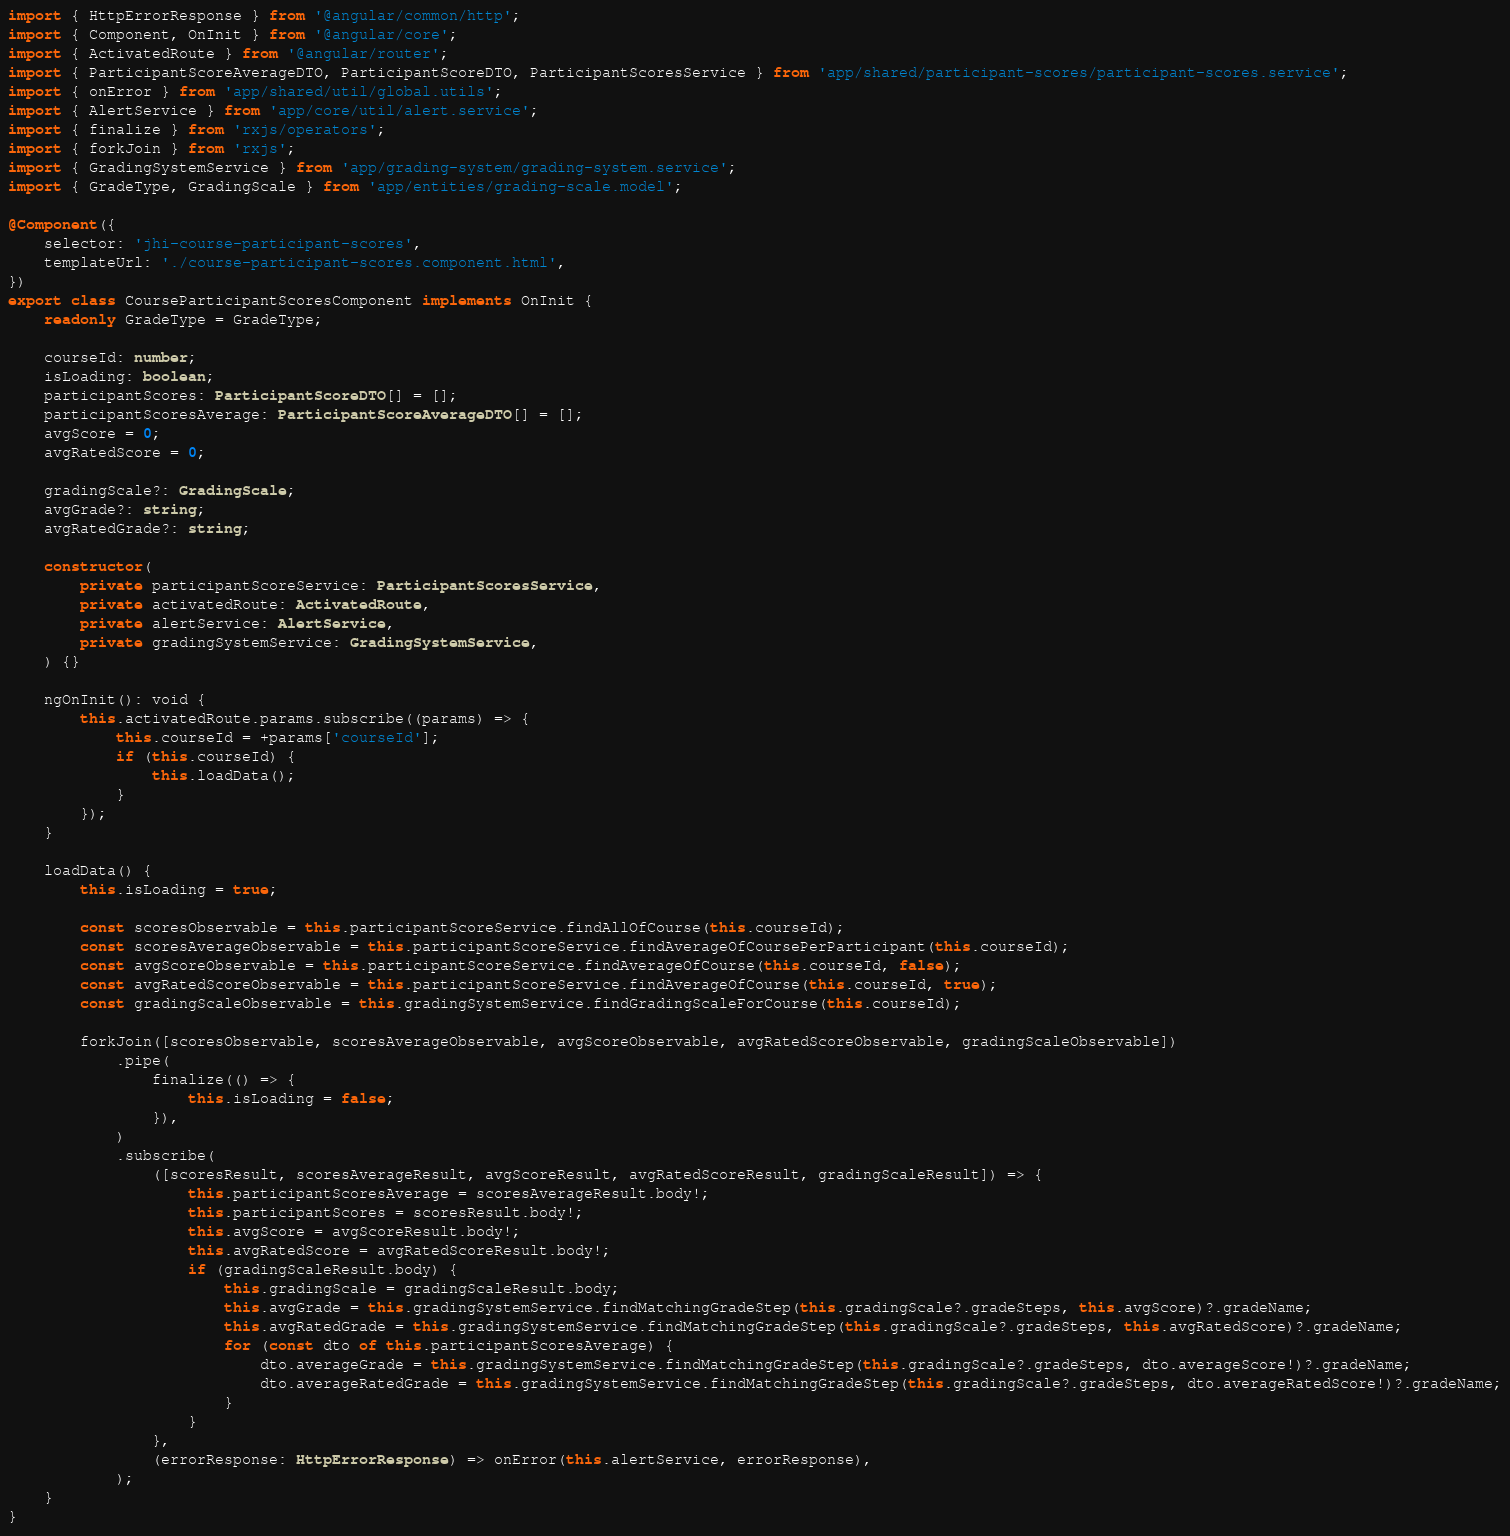Convert code to text. <code><loc_0><loc_0><loc_500><loc_500><_TypeScript_>import { HttpErrorResponse } from '@angular/common/http';
import { Component, OnInit } from '@angular/core';
import { ActivatedRoute } from '@angular/router';
import { ParticipantScoreAverageDTO, ParticipantScoreDTO, ParticipantScoresService } from 'app/shared/participant-scores/participant-scores.service';
import { onError } from 'app/shared/util/global.utils';
import { AlertService } from 'app/core/util/alert.service';
import { finalize } from 'rxjs/operators';
import { forkJoin } from 'rxjs';
import { GradingSystemService } from 'app/grading-system/grading-system.service';
import { GradeType, GradingScale } from 'app/entities/grading-scale.model';

@Component({
    selector: 'jhi-course-participant-scores',
    templateUrl: './course-participant-scores.component.html',
})
export class CourseParticipantScoresComponent implements OnInit {
    readonly GradeType = GradeType;

    courseId: number;
    isLoading: boolean;
    participantScores: ParticipantScoreDTO[] = [];
    participantScoresAverage: ParticipantScoreAverageDTO[] = [];
    avgScore = 0;
    avgRatedScore = 0;

    gradingScale?: GradingScale;
    avgGrade?: string;
    avgRatedGrade?: string;

    constructor(
        private participantScoreService: ParticipantScoresService,
        private activatedRoute: ActivatedRoute,
        private alertService: AlertService,
        private gradingSystemService: GradingSystemService,
    ) {}

    ngOnInit(): void {
        this.activatedRoute.params.subscribe((params) => {
            this.courseId = +params['courseId'];
            if (this.courseId) {
                this.loadData();
            }
        });
    }

    loadData() {
        this.isLoading = true;

        const scoresObservable = this.participantScoreService.findAllOfCourse(this.courseId);
        const scoresAverageObservable = this.participantScoreService.findAverageOfCoursePerParticipant(this.courseId);
        const avgScoreObservable = this.participantScoreService.findAverageOfCourse(this.courseId, false);
        const avgRatedScoreObservable = this.participantScoreService.findAverageOfCourse(this.courseId, true);
        const gradingScaleObservable = this.gradingSystemService.findGradingScaleForCourse(this.courseId);

        forkJoin([scoresObservable, scoresAverageObservable, avgScoreObservable, avgRatedScoreObservable, gradingScaleObservable])
            .pipe(
                finalize(() => {
                    this.isLoading = false;
                }),
            )
            .subscribe(
                ([scoresResult, scoresAverageResult, avgScoreResult, avgRatedScoreResult, gradingScaleResult]) => {
                    this.participantScoresAverage = scoresAverageResult.body!;
                    this.participantScores = scoresResult.body!;
                    this.avgScore = avgScoreResult.body!;
                    this.avgRatedScore = avgRatedScoreResult.body!;
                    if (gradingScaleResult.body) {
                        this.gradingScale = gradingScaleResult.body;
                        this.avgGrade = this.gradingSystemService.findMatchingGradeStep(this.gradingScale?.gradeSteps, this.avgScore)?.gradeName;
                        this.avgRatedGrade = this.gradingSystemService.findMatchingGradeStep(this.gradingScale?.gradeSteps, this.avgRatedScore)?.gradeName;
                        for (const dto of this.participantScoresAverage) {
                            dto.averageGrade = this.gradingSystemService.findMatchingGradeStep(this.gradingScale?.gradeSteps, dto.averageScore!)?.gradeName;
                            dto.averageRatedGrade = this.gradingSystemService.findMatchingGradeStep(this.gradingScale?.gradeSteps, dto.averageRatedScore!)?.gradeName;
                        }
                    }
                },
                (errorResponse: HttpErrorResponse) => onError(this.alertService, errorResponse),
            );
    }
}
</code> 